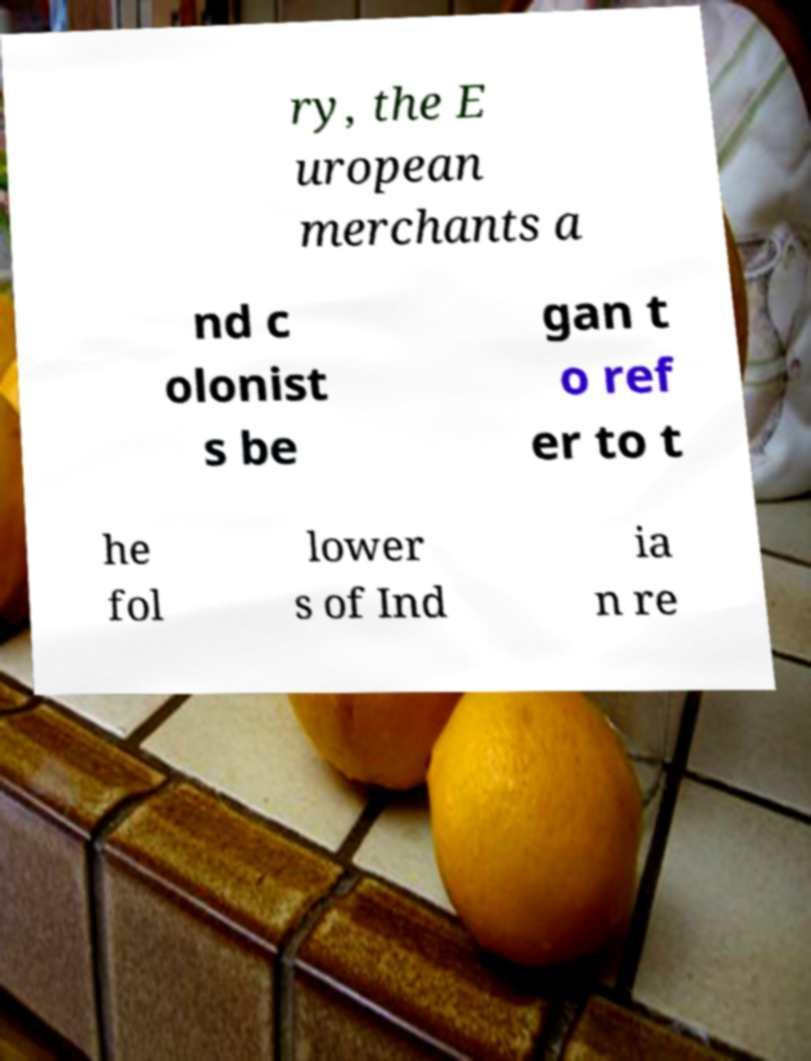Please read and relay the text visible in this image. What does it say? ry, the E uropean merchants a nd c olonist s be gan t o ref er to t he fol lower s of Ind ia n re 